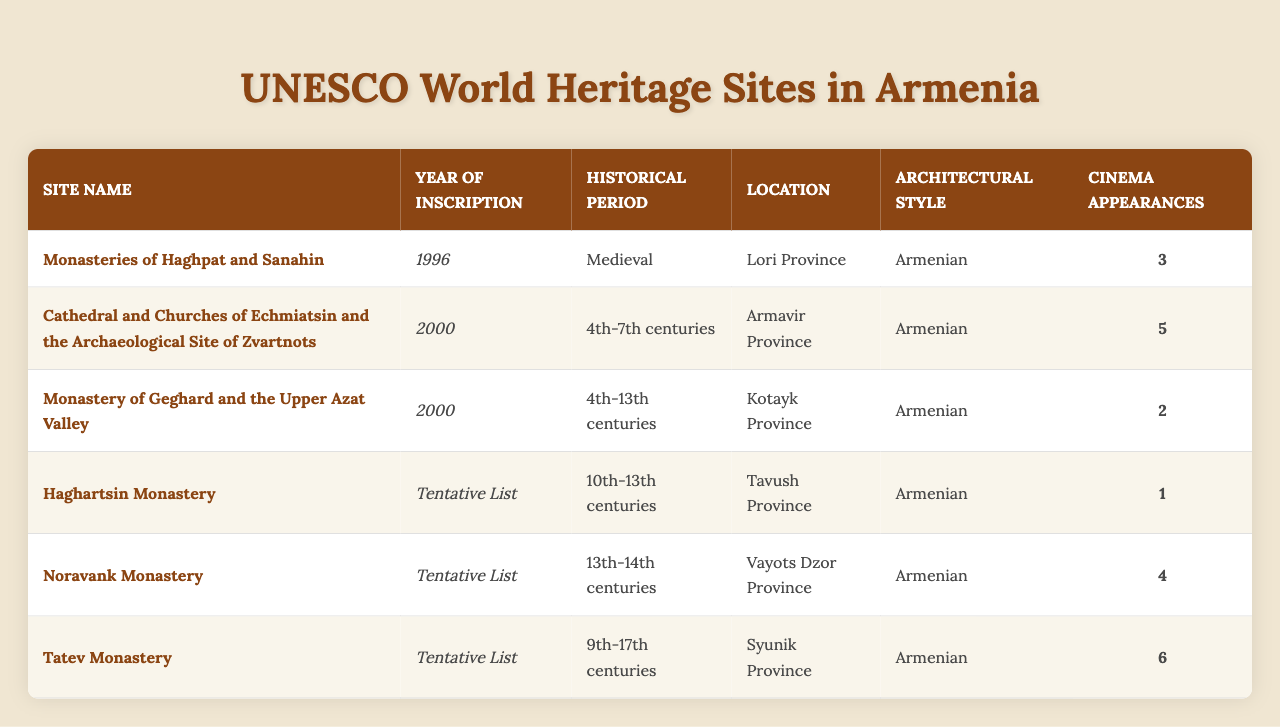What year was the Monasteries of Haghpat and Sanahin inscribed as a UNESCO World Heritage Site? The table shows that the Monasteries of Haghpat and Sanahin was inscribed in the year 1996.
Answer: 1996 How many UNESCO World Heritage Sites were inscribed in the year 2000? There are two sites inscribed in the year 2000: the Cathedral and Churches of Echmiatsin and the Archaeological Site of Zvartnots, and the Monastery of Geghard and the Upper Azat Valley.
Answer: 2 Which site has the most cinema appearances? The Tatev Monastery has the highest number of cinema appearances, totaling 6.
Answer: 6 Is the Haghartsin Monastery on the tentative list for UNESCO World Heritage Sites? Yes, the Haghartsin Monastery is listed as "Tentative List" in the year of inscription column.
Answer: Yes What is the average number of cinema appearances for sites inscribed in year 2000? The two sites inscribed in 2000 are the Cathedral and Churches of Echmiatsin and the Archaeological Site of Zvartnots (5 appearances) and the Monastery of Geghard and the Upper Azat Valley (2 appearances). Therefore, the average is (5 + 2) / 2 = 3.5.
Answer: 3.5 Which site is located in Vayots Dzor Province? The table indicates that the Noravank Monastery is located in Vayots Dzor Province.
Answer: Noravank Monastery How many historical periods are covered by the sites listed in the table? The site historical periods include "Medieval," "4th-7th centuries," "4th-13th centuries," "10th-13th centuries," "13th-14th centuries," and "9th-17th centuries," totaling 6 distinct historical periods.
Answer: 6 If we combine cinema appearances from all sites on the tentative list, what is the total? Adding the cinema appearances from Haghartsin Monastery (1), Noravank Monastery (4), and Tatev Monastery (6) gives a total of 1 + 4 + 6 = 11.
Answer: 11 What is the difference between the cinema appearances of the site with the most appearances and the site with the least? The Tatev Monastery has 6 appearances and the Haghartsin Monastery has 1 appearance. The difference is 6 - 1 = 5.
Answer: 5 Which site has its historical period listed as the 4th-7th centuries? The Cathedral and Churches of Echmiatsin and the Archaeological Site of Zvartnots has its historical period listed as the 4th-7th centuries.
Answer: Cathedral and Churches of Echmiatsin and the Archaeological Site of Zvartnots 